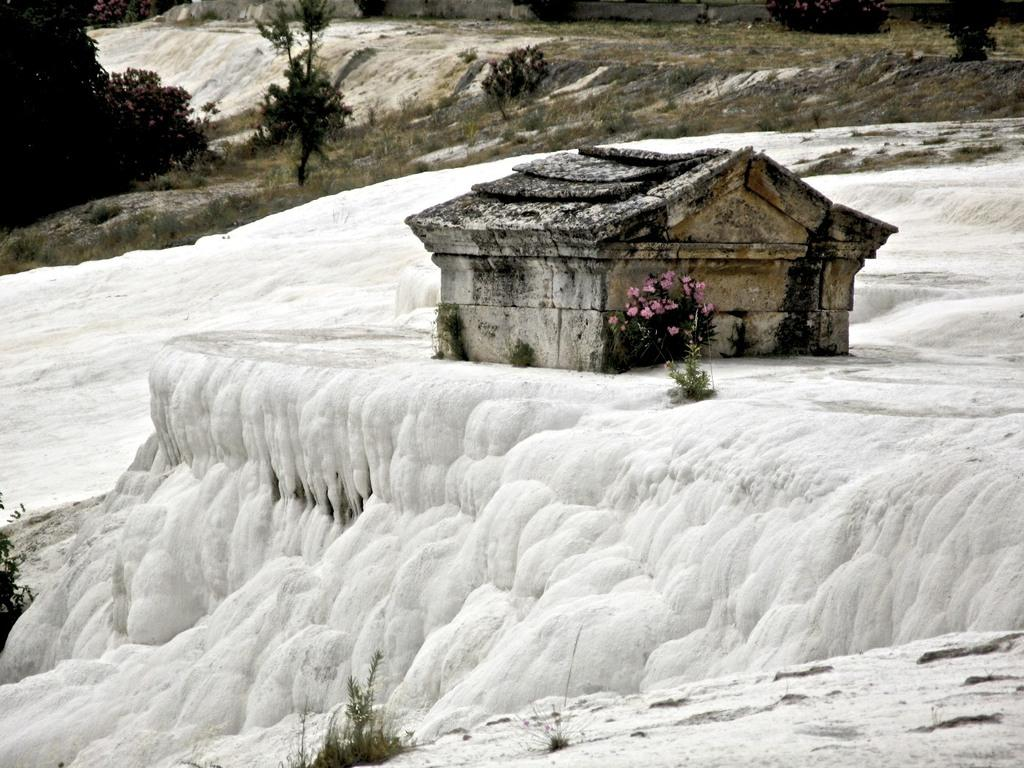What is covering the ground in the image? There is snow on the ground in the image. What can be seen in the middle of the image? There is a stone structure in the middle of the image. What type of vegetation is visible in the image? There are plants visible in the image. What specific type of plant can be seen in the image? There are flowers visible in the image. How many times does the person in the image cough while walking on the slope? There is no person in the image, nor is there a slope present. 